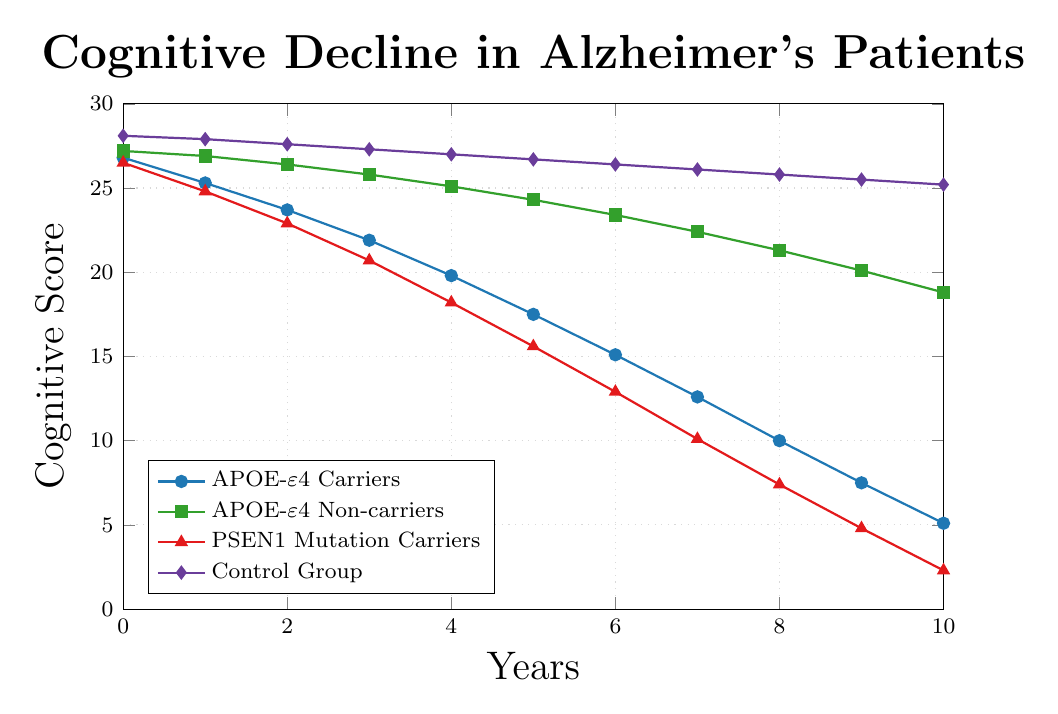What is the cognitive score of APOE-ε4 Carriers at year 3? The data point for APOE-ε4 Carriers at year 3 is shown by the blue line with circles, and the score is found at the intersection.
Answer: 21.9 Which group experiences the steepest decline in cognitive score over the 10-year period? To determine which group experiences the steepest decline, we compare the starting and ending scores for each group over the 10 years. APOE-ε4 Carriers drop from 26.8 to 5.1, APOE-ε4 Non-carriers from 27.2 to 18.8, PSEN1 Mutation Carriers from 26.5 to 2.3, and Control Group from 28.1 to 25.2. PSEN1 Mutation Carriers exhibit the largest decline.
Answer: PSEN1 Mutation Carriers What is the difference in cognitive score between the Control Group and APOE-ε4 Carriers at year 6? Look at the cognitive scores for both the Control Group and APOE-ε4 Carriers at year 6. The Control Group has a score of 26.4, and APOE-ε4 Carriers have a score of 15.1. Calculate the difference: 26.4 - 15.1 = 11.3.
Answer: 11.3 By how much did the cognitive score of APOE-ε4 Non-carriers decrease from year 0 to year 10? The initial score for APOE-ε4 Non-carriers at year 0 is 27.2, and by year 10, it decreases to 18.8. The decrease is calculated as 27.2 - 18.8.
Answer: 8.4 Which group has the highest cognitive score at year 5? Look at the scores for all groups at year 5. The Control Group has a score of 26.7, which is the highest among all groups.
Answer: Control Group Compare the cognitive scores of APOE-ε4 Carriers and PSEN1 Mutation Carriers at year 8. Which group has a higher score, and by how much? At year 8, APOE-ε4 Carriers have a score of 10, while PSEN1 Mutation Carriers have a score of 7.4. Calculate the difference: 10 - 7.4. APOE-ε4 Carriers have a higher score by 2.6.
Answer: APOE-ε4 Carriers, by 2.6 What is the average cognitive score for PSEN1 Mutation Carriers over the 10-year period? To find the average score for PSEN1 Mutation Carriers, sum their scores from year 0 to year 10 and divide by the number of years (11). Their scores are: [26.5, 24.8, 22.9, 20.7, 18.2, 15.6, 12.9, 10.1, 7.4, 4.8, 2.3]. Sum = 166.2. Average = 166.2/11 = 15.11 (rounded)
Answer: 15.11 Which group shows the smallest decline in cognitive score from year 0 to year 10? Compare the declines in cognitive scores for all groups from year 0 to year 10. The declines are: APOE-ε4 Carriers (26.8 to 5.1), APOE-ε4 Non-carriers (27.2 to 18.8), PSEN1 Mutation Carriers (26.5 to 2.3), Control Group (28.1 to 25.2). Control Group shows the smallest decline.
Answer: Control Group At what year does the cognitive score of APOE-ε4 Non-carriers first drop below 25? Trace the green line with squares representing APOE-ε4 Non-carriers and find the year where the score first falls below 25. This occurs at year 4.
Answer: Year 4 